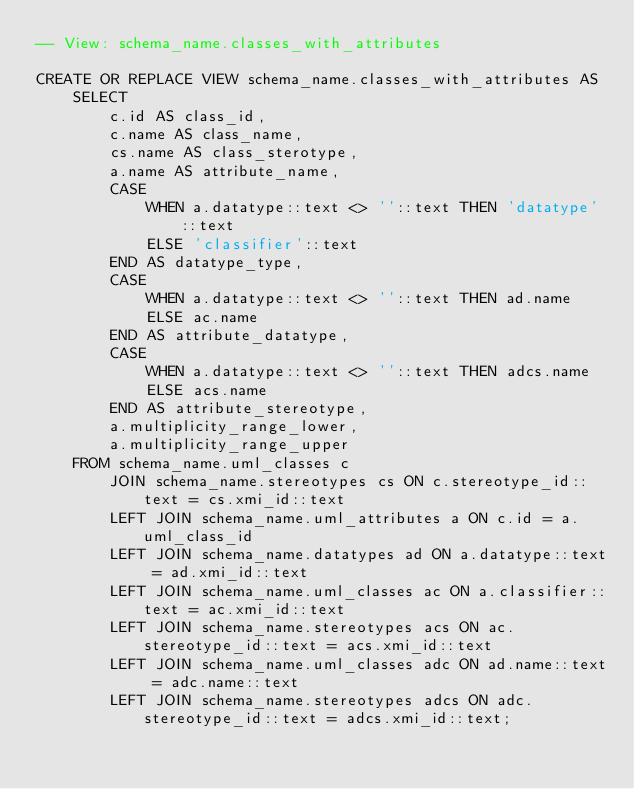Convert code to text. <code><loc_0><loc_0><loc_500><loc_500><_SQL_>-- View: schema_name.classes_with_attributes

CREATE OR REPLACE VIEW schema_name.classes_with_attributes AS 
	SELECT
		c.id AS class_id,
		c.name AS class_name,
		cs.name AS class_sterotype,
		a.name AS attribute_name, 
		CASE
			WHEN a.datatype::text <> ''::text THEN 'datatype'::text
			ELSE 'classifier'::text
		END AS datatype_type, 
		CASE
			WHEN a.datatype::text <> ''::text THEN ad.name
			ELSE ac.name
		END AS attribute_datatype, 
		CASE
			WHEN a.datatype::text <> ''::text THEN adcs.name
			ELSE acs.name
		END AS attribute_stereotype,
		a.multiplicity_range_lower,
		a.multiplicity_range_upper
	FROM schema_name.uml_classes c
		JOIN schema_name.stereotypes cs ON c.stereotype_id::text = cs.xmi_id::text
		LEFT JOIN schema_name.uml_attributes a ON c.id = a.uml_class_id
		LEFT JOIN schema_name.datatypes ad ON a.datatype::text = ad.xmi_id::text
		LEFT JOIN schema_name.uml_classes ac ON a.classifier::text = ac.xmi_id::text
		LEFT JOIN schema_name.stereotypes acs ON ac.stereotype_id::text = acs.xmi_id::text
		LEFT JOIN schema_name.uml_classes adc ON ad.name::text = adc.name::text
		LEFT JOIN schema_name.stereotypes adcs ON adc.stereotype_id::text = adcs.xmi_id::text;</code> 